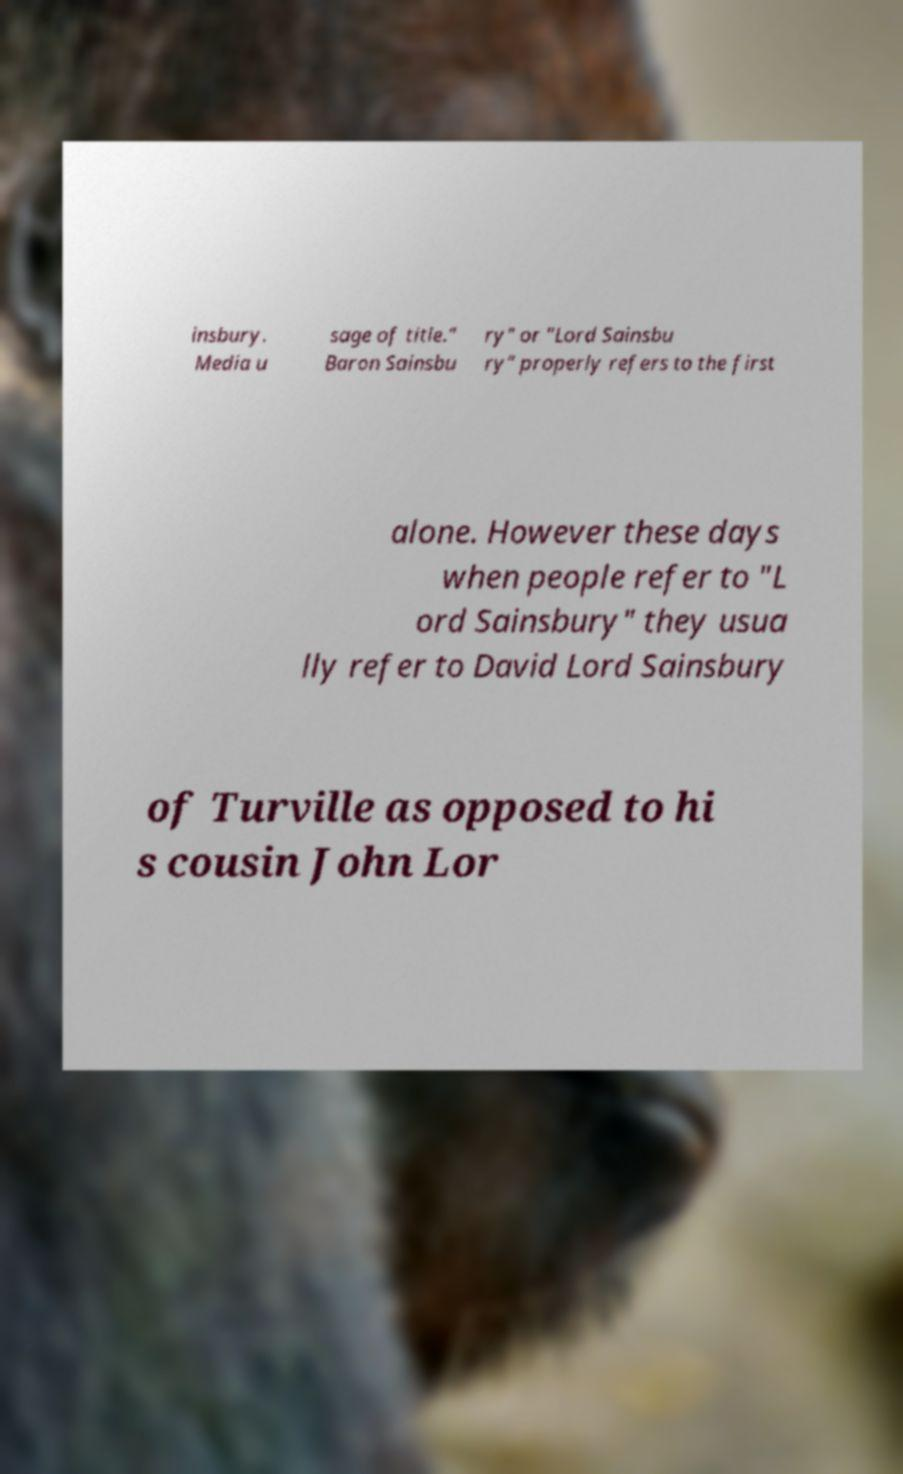There's text embedded in this image that I need extracted. Can you transcribe it verbatim? insbury. Media u sage of title." Baron Sainsbu ry" or "Lord Sainsbu ry" properly refers to the first alone. However these days when people refer to "L ord Sainsbury" they usua lly refer to David Lord Sainsbury of Turville as opposed to hi s cousin John Lor 